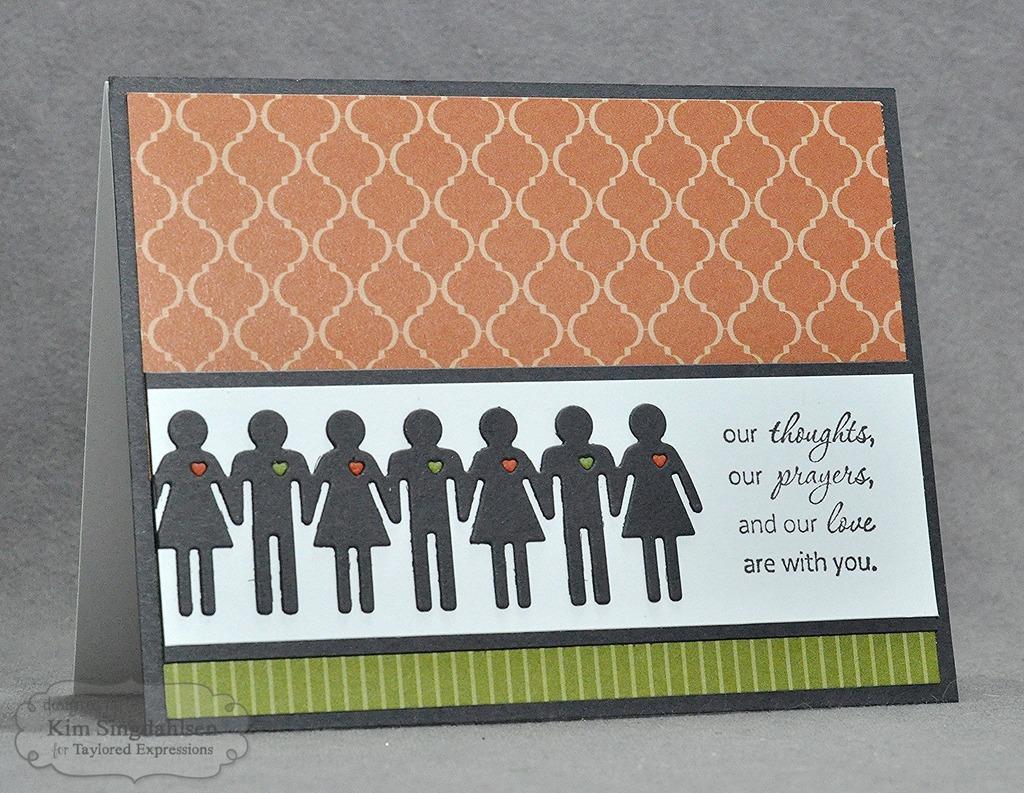Can you describe this image briefly? In the image we can see the greeting and in the greeting we can see cartoon images and some text. On the bottom left, we can see the watermark. 